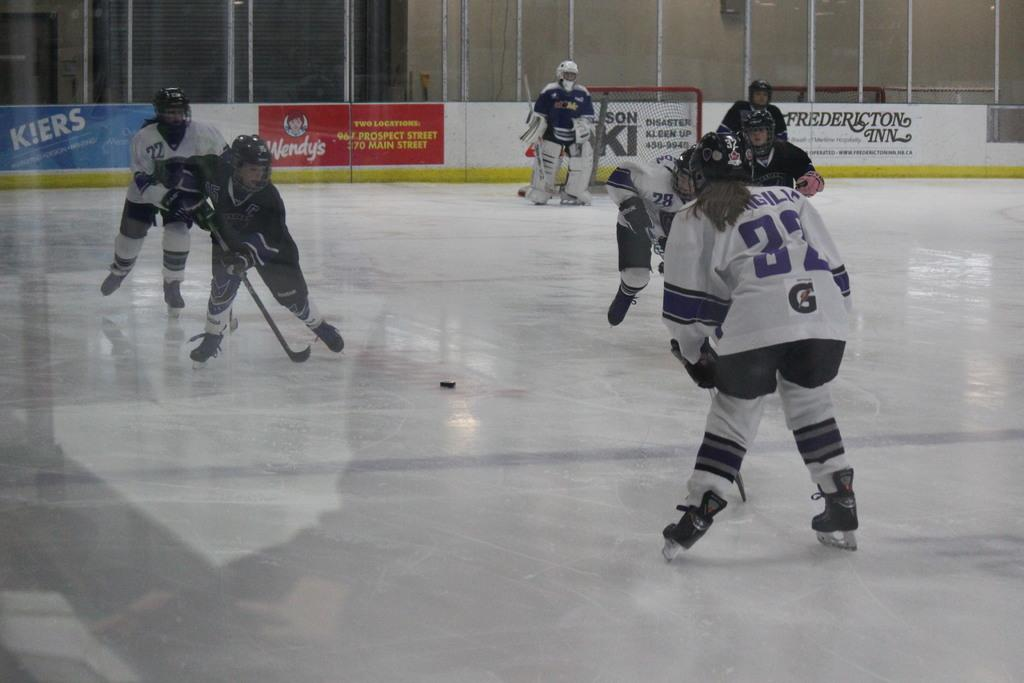What is the main subject of the image? The main subject of the image is a group of lady persons. What are the lady persons wearing? The lady persons are wearing sports dress and helmets. What sport are they playing? They are playing ice hockey. What can be seen in the background of the image? There is fencing and a board in the background of the image. Can you see any snails on the ice hockey rink in the image? There are no snails visible on the ice hockey rink in the image. What type of hair is visible on the lady persons in the image? The image does not show the hair of the lady persons, as they are wearing helmets. 